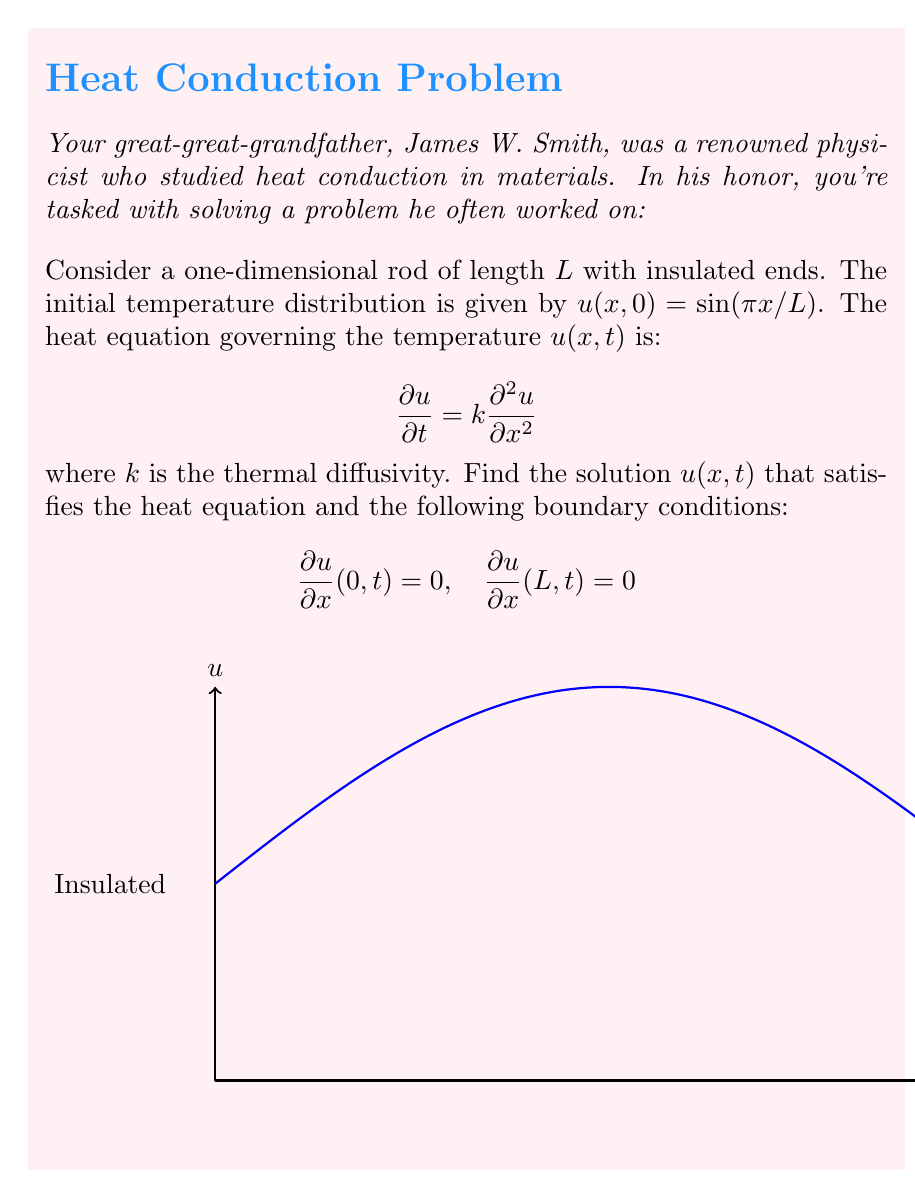Could you help me with this problem? Let's solve this problem step by step:

1) The heat equation with insulated ends suggests we should use separation of variables. Let $u(x,t) = X(x)T(t)$.

2) Substituting into the heat equation:

   $$X(x)T'(t) = kX''(x)T(t)$$

3) Dividing both sides by $kX(x)T(t)$:

   $$\frac{T'(t)}{kT(t)} = \frac{X''(x)}{X(x)} = -\lambda$$

   where $-\lambda$ is a separation constant.

4) This gives us two ODEs:
   
   $$T'(t) + k\lambda T(t) = 0$$
   $$X''(x) + \lambda X(x) = 0$$

5) The boundary conditions in terms of $X(x)$ are:
   
   $$X'(0) = 0, \quad X'(L) = 0$$

6) The general solution for $X(x)$ is:

   $$X(x) = A\cos(\sqrt{\lambda}x) + B\sin(\sqrt{\lambda}x)$$

7) Applying the boundary conditions:
   
   $X'(0) = 0$ implies $B = 0$
   $X'(L) = 0$ implies $\sin(\sqrt{\lambda}L) = 0$

8) This means $\sqrt{\lambda}L = n\pi$ or $\lambda_n = (\frac{n\pi}{L})^2$ for $n = 0,1,2,\ldots$

9) The eigenfunctions are:

   $$X_n(x) = \cos(\frac{n\pi x}{L})$$

10) The solution for $T(t)$ is:

    $$T_n(t) = e^{-k(\frac{n\pi}{L})^2t}$$

11) The general solution is:

    $$u(x,t) = \sum_{n=0}^{\infty} c_n\cos(\frac{n\pi x}{L})e^{-k(\frac{n\pi}{L})^2t}$$

12) Using the initial condition $u(x,0) = \sin(\pi x/L)$, we can determine the coefficients:

    $$\sin(\frac{\pi x}{L}) = \sum_{n=0}^{\infty} c_n\cos(\frac{n\pi x}{L})$$

13) This implies $c_1 = 1$ and all other $c_n = 0$.

Therefore, the final solution is:

$$u(x,t) = \sin(\frac{\pi x}{L})e^{-k(\frac{\pi}{L})^2t}$$
Answer: $u(x,t) = \sin(\frac{\pi x}{L})e^{-k(\frac{\pi}{L})^2t}$ 